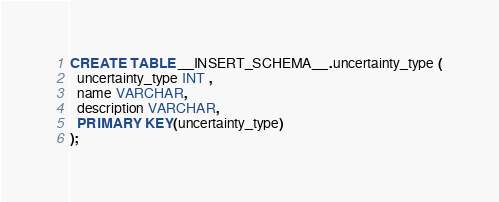Convert code to text. <code><loc_0><loc_0><loc_500><loc_500><_SQL_>CREATE TABLE __INSERT_SCHEMA__.uncertainty_type (
  uncertainty_type INT ,
  name VARCHAR,
  description VARCHAR,
  PRIMARY KEY(uncertainty_type)
);
</code> 